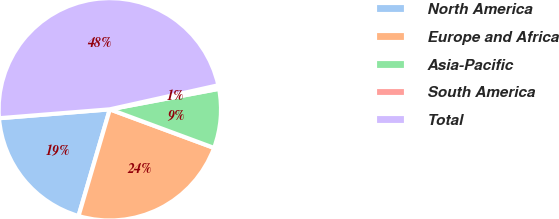Convert chart to OTSL. <chart><loc_0><loc_0><loc_500><loc_500><pie_chart><fcel>North America<fcel>Europe and Africa<fcel>Asia-Pacific<fcel>South America<fcel>Total<nl><fcel>19.18%<fcel>23.9%<fcel>8.6%<fcel>0.52%<fcel>47.8%<nl></chart> 